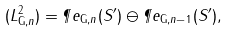Convert formula to latex. <formula><loc_0><loc_0><loc_500><loc_500>( L ^ { 2 } _ { { \mathrm G } , n } ) = \P e _ { { \mathrm G } , n } ( S ^ { \prime } ) \ominus \P e _ { { \mathrm G } , n - 1 } ( S ^ { \prime } ) ,</formula> 